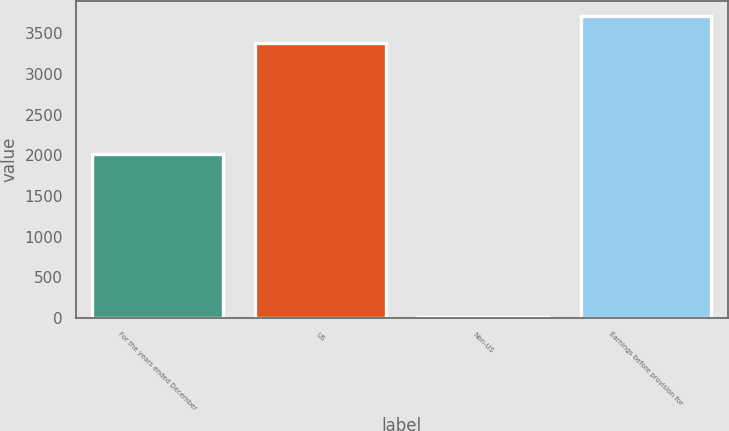Convert chart. <chart><loc_0><loc_0><loc_500><loc_500><bar_chart><fcel>For the years ended December<fcel>US<fcel>Non-US<fcel>Earnings before provision for<nl><fcel>2014<fcel>3377<fcel>9<fcel>3714.7<nl></chart> 